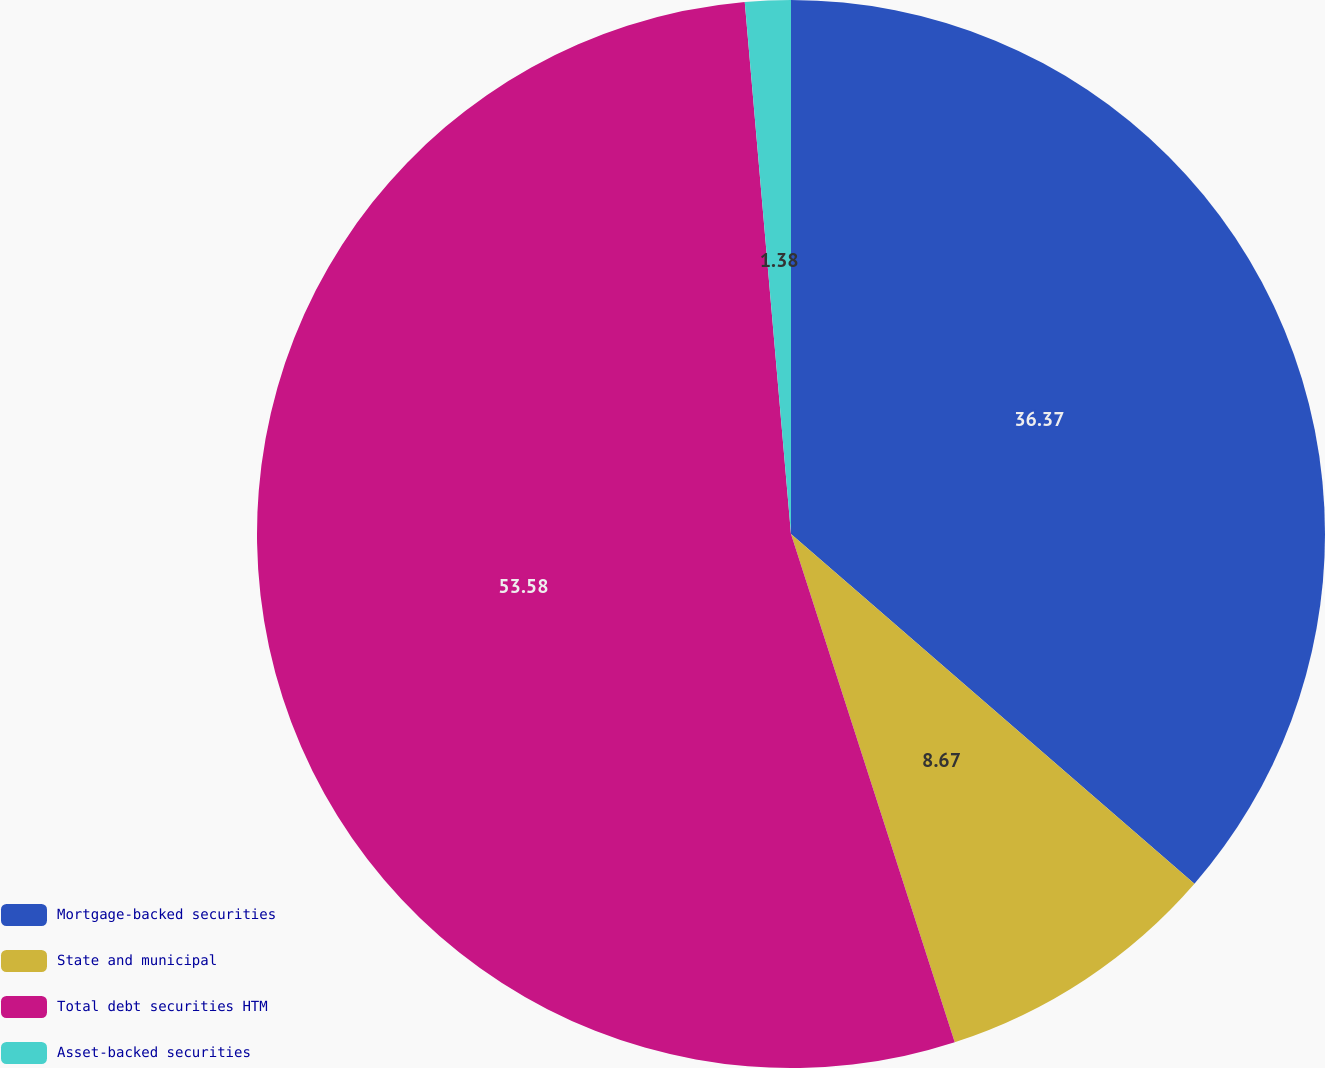Convert chart. <chart><loc_0><loc_0><loc_500><loc_500><pie_chart><fcel>Mortgage-backed securities<fcel>State and municipal<fcel>Total debt securities HTM<fcel>Asset-backed securities<nl><fcel>36.37%<fcel>8.67%<fcel>53.58%<fcel>1.38%<nl></chart> 